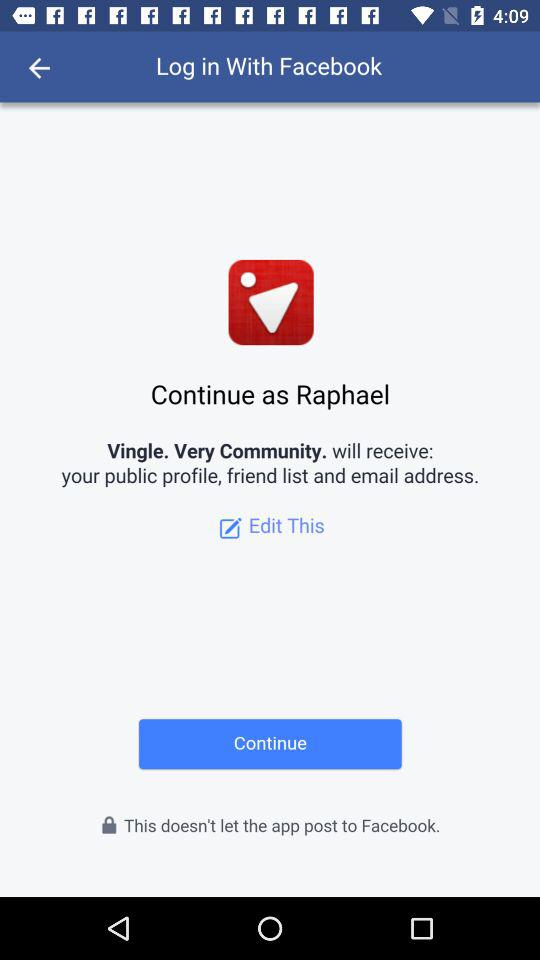What application is asking for permission? The application asking for permission is "Vingle. Very Community.". 